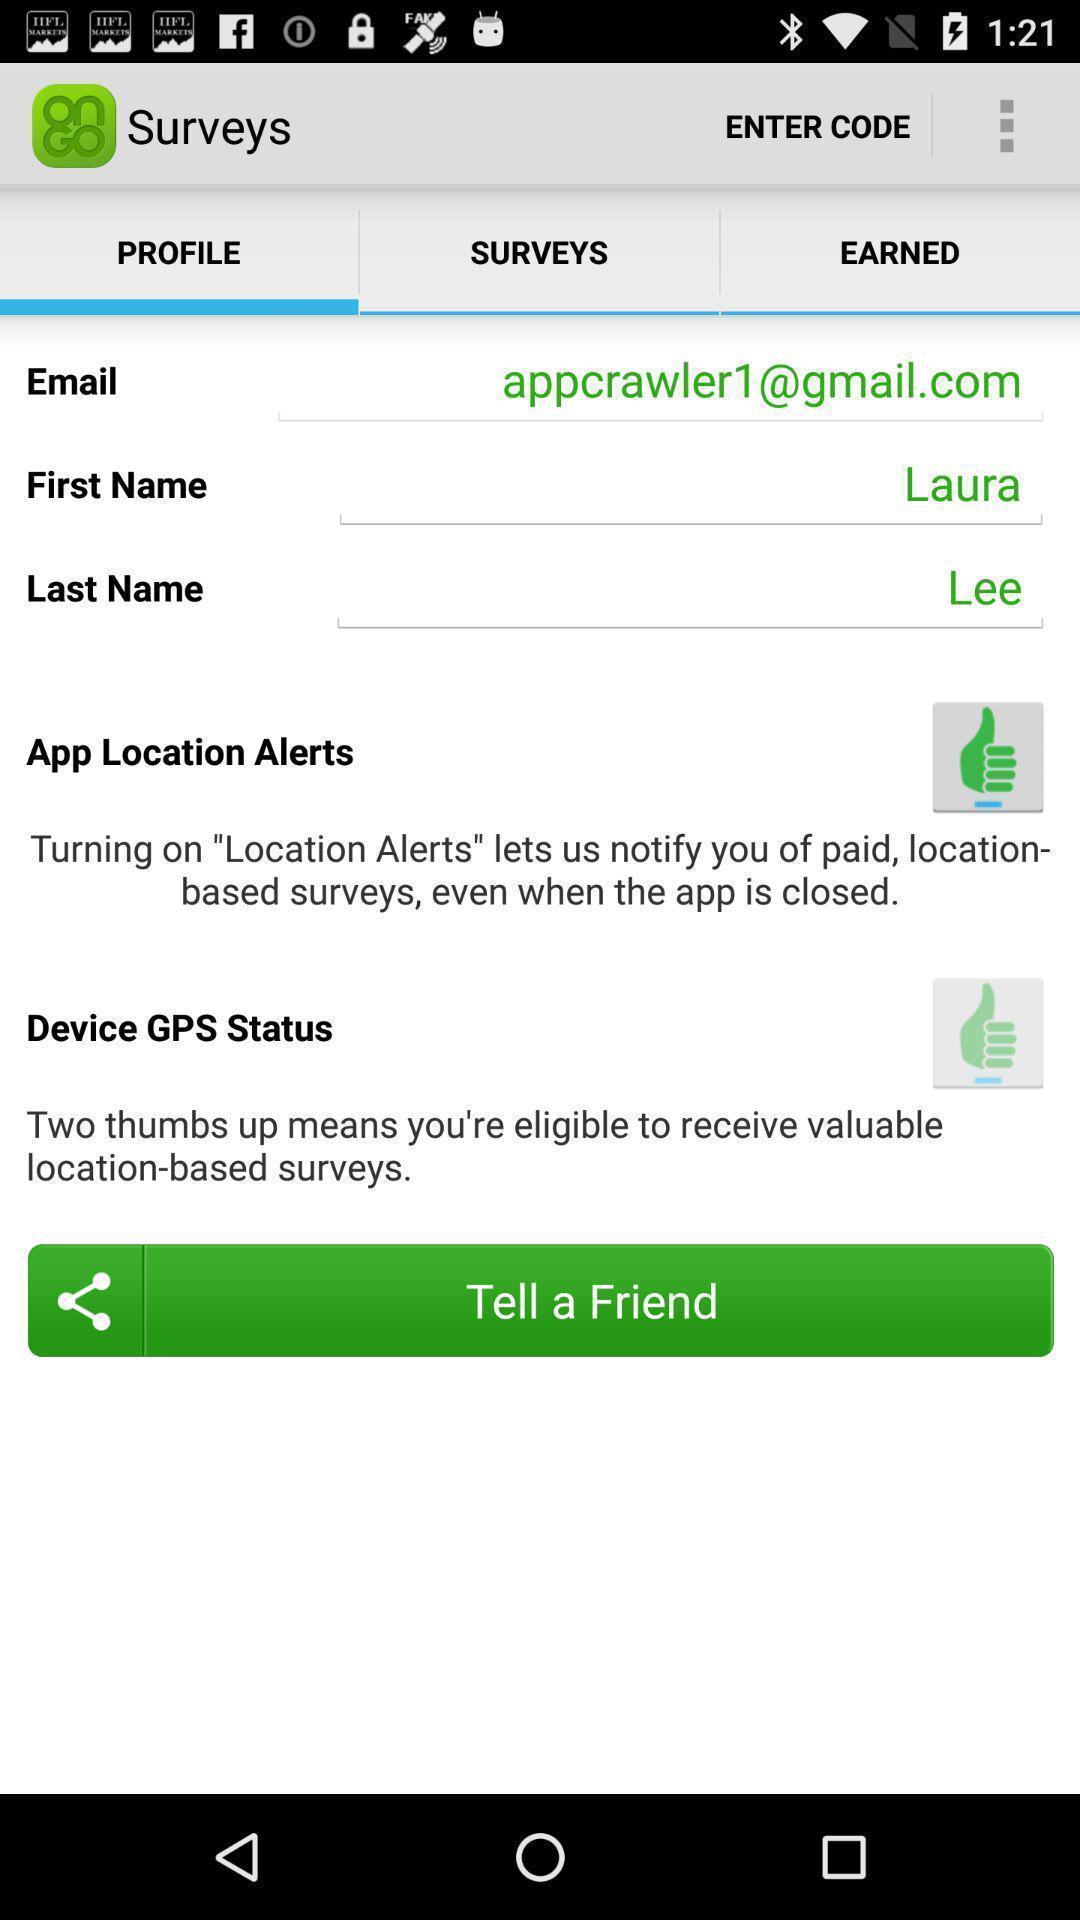Summarize the main components in this picture. Survey application with profile details in mobile. 